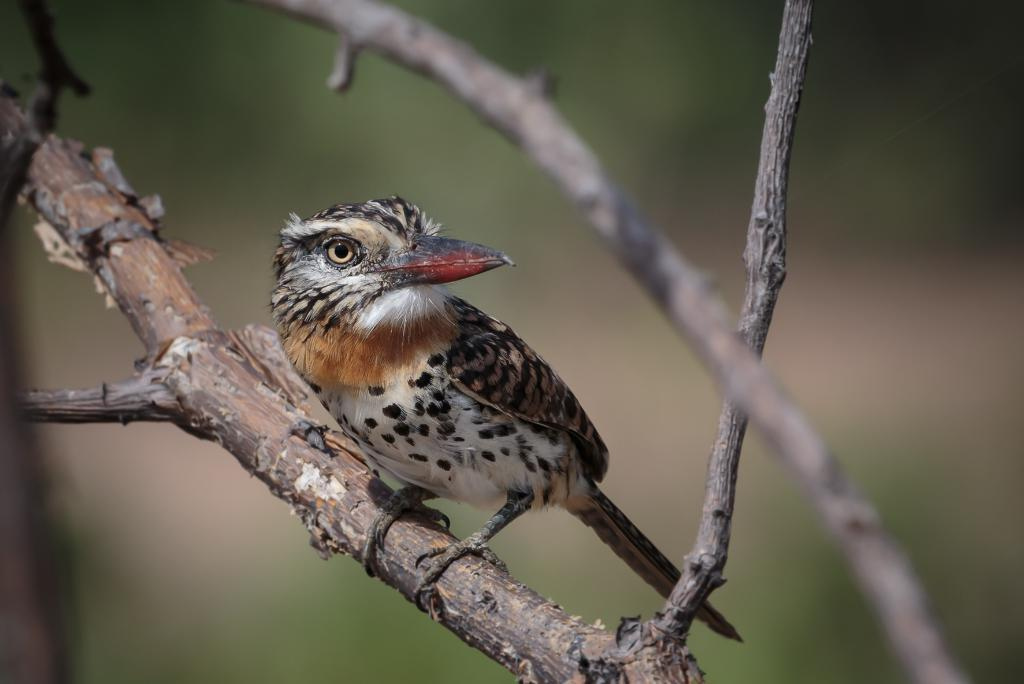What type of animal can be seen in the image? There is a bird in the image. Where is the bird located? The bird is sitting on a tree trunk. Can you describe the background of the image? The background of the image is blurred. What is the fastest route for the cars to take in the image? There are no cars present in the image, so it is not possible to determine the fastest route. 